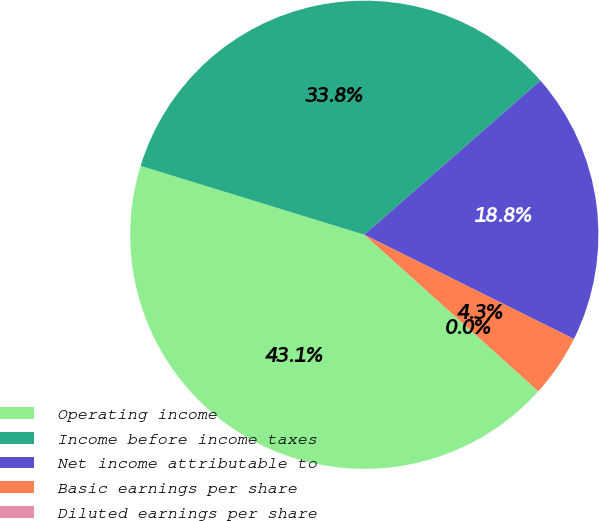<chart> <loc_0><loc_0><loc_500><loc_500><pie_chart><fcel>Operating income<fcel>Income before income taxes<fcel>Net income attributable to<fcel>Basic earnings per share<fcel>Diluted earnings per share<nl><fcel>43.09%<fcel>33.8%<fcel>18.79%<fcel>4.31%<fcel>0.0%<nl></chart> 